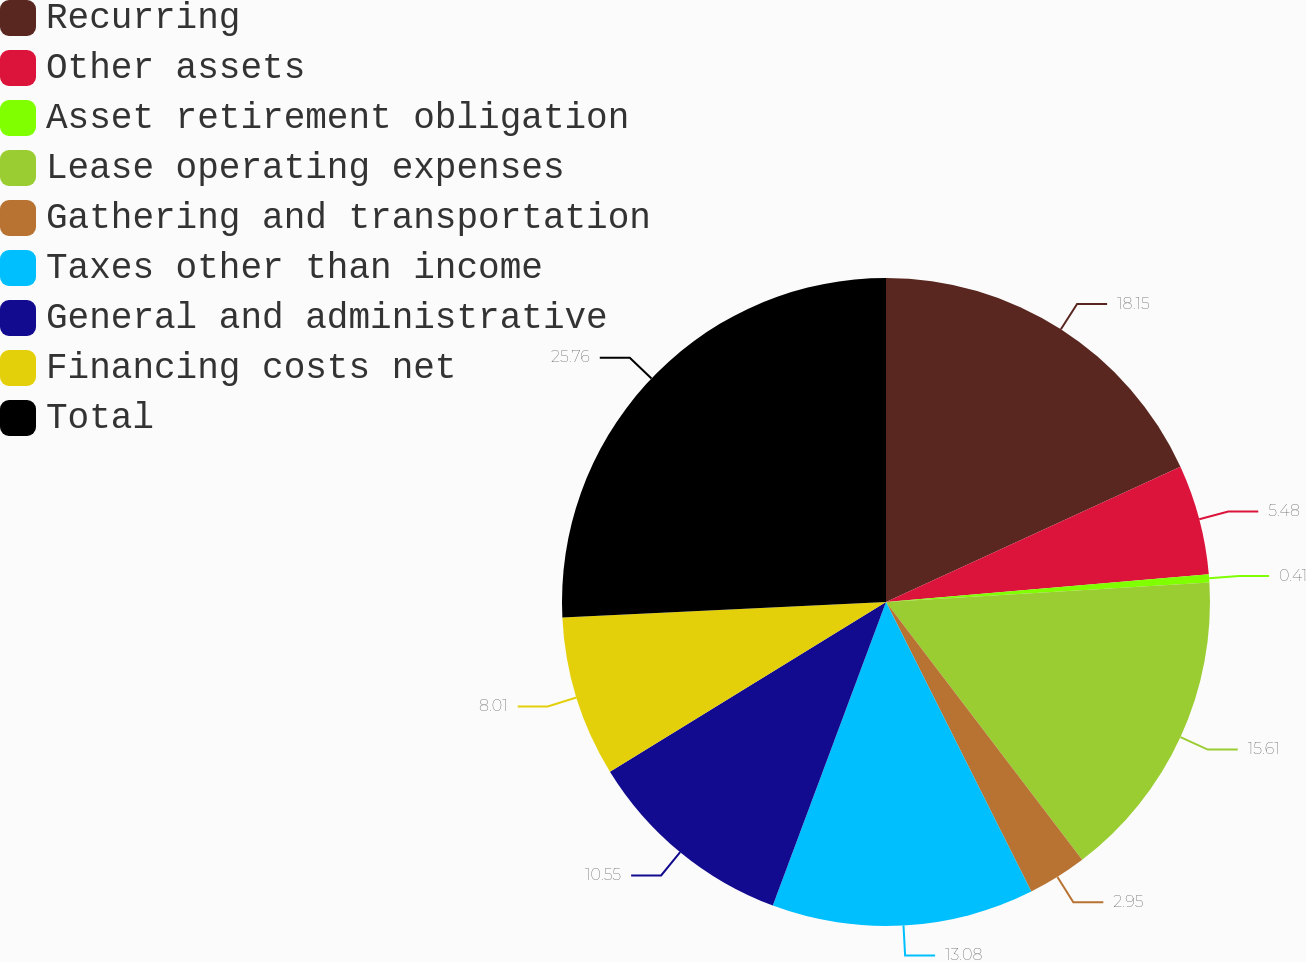Convert chart to OTSL. <chart><loc_0><loc_0><loc_500><loc_500><pie_chart><fcel>Recurring<fcel>Other assets<fcel>Asset retirement obligation<fcel>Lease operating expenses<fcel>Gathering and transportation<fcel>Taxes other than income<fcel>General and administrative<fcel>Financing costs net<fcel>Total<nl><fcel>18.15%<fcel>5.48%<fcel>0.41%<fcel>15.61%<fcel>2.95%<fcel>13.08%<fcel>10.55%<fcel>8.01%<fcel>25.76%<nl></chart> 